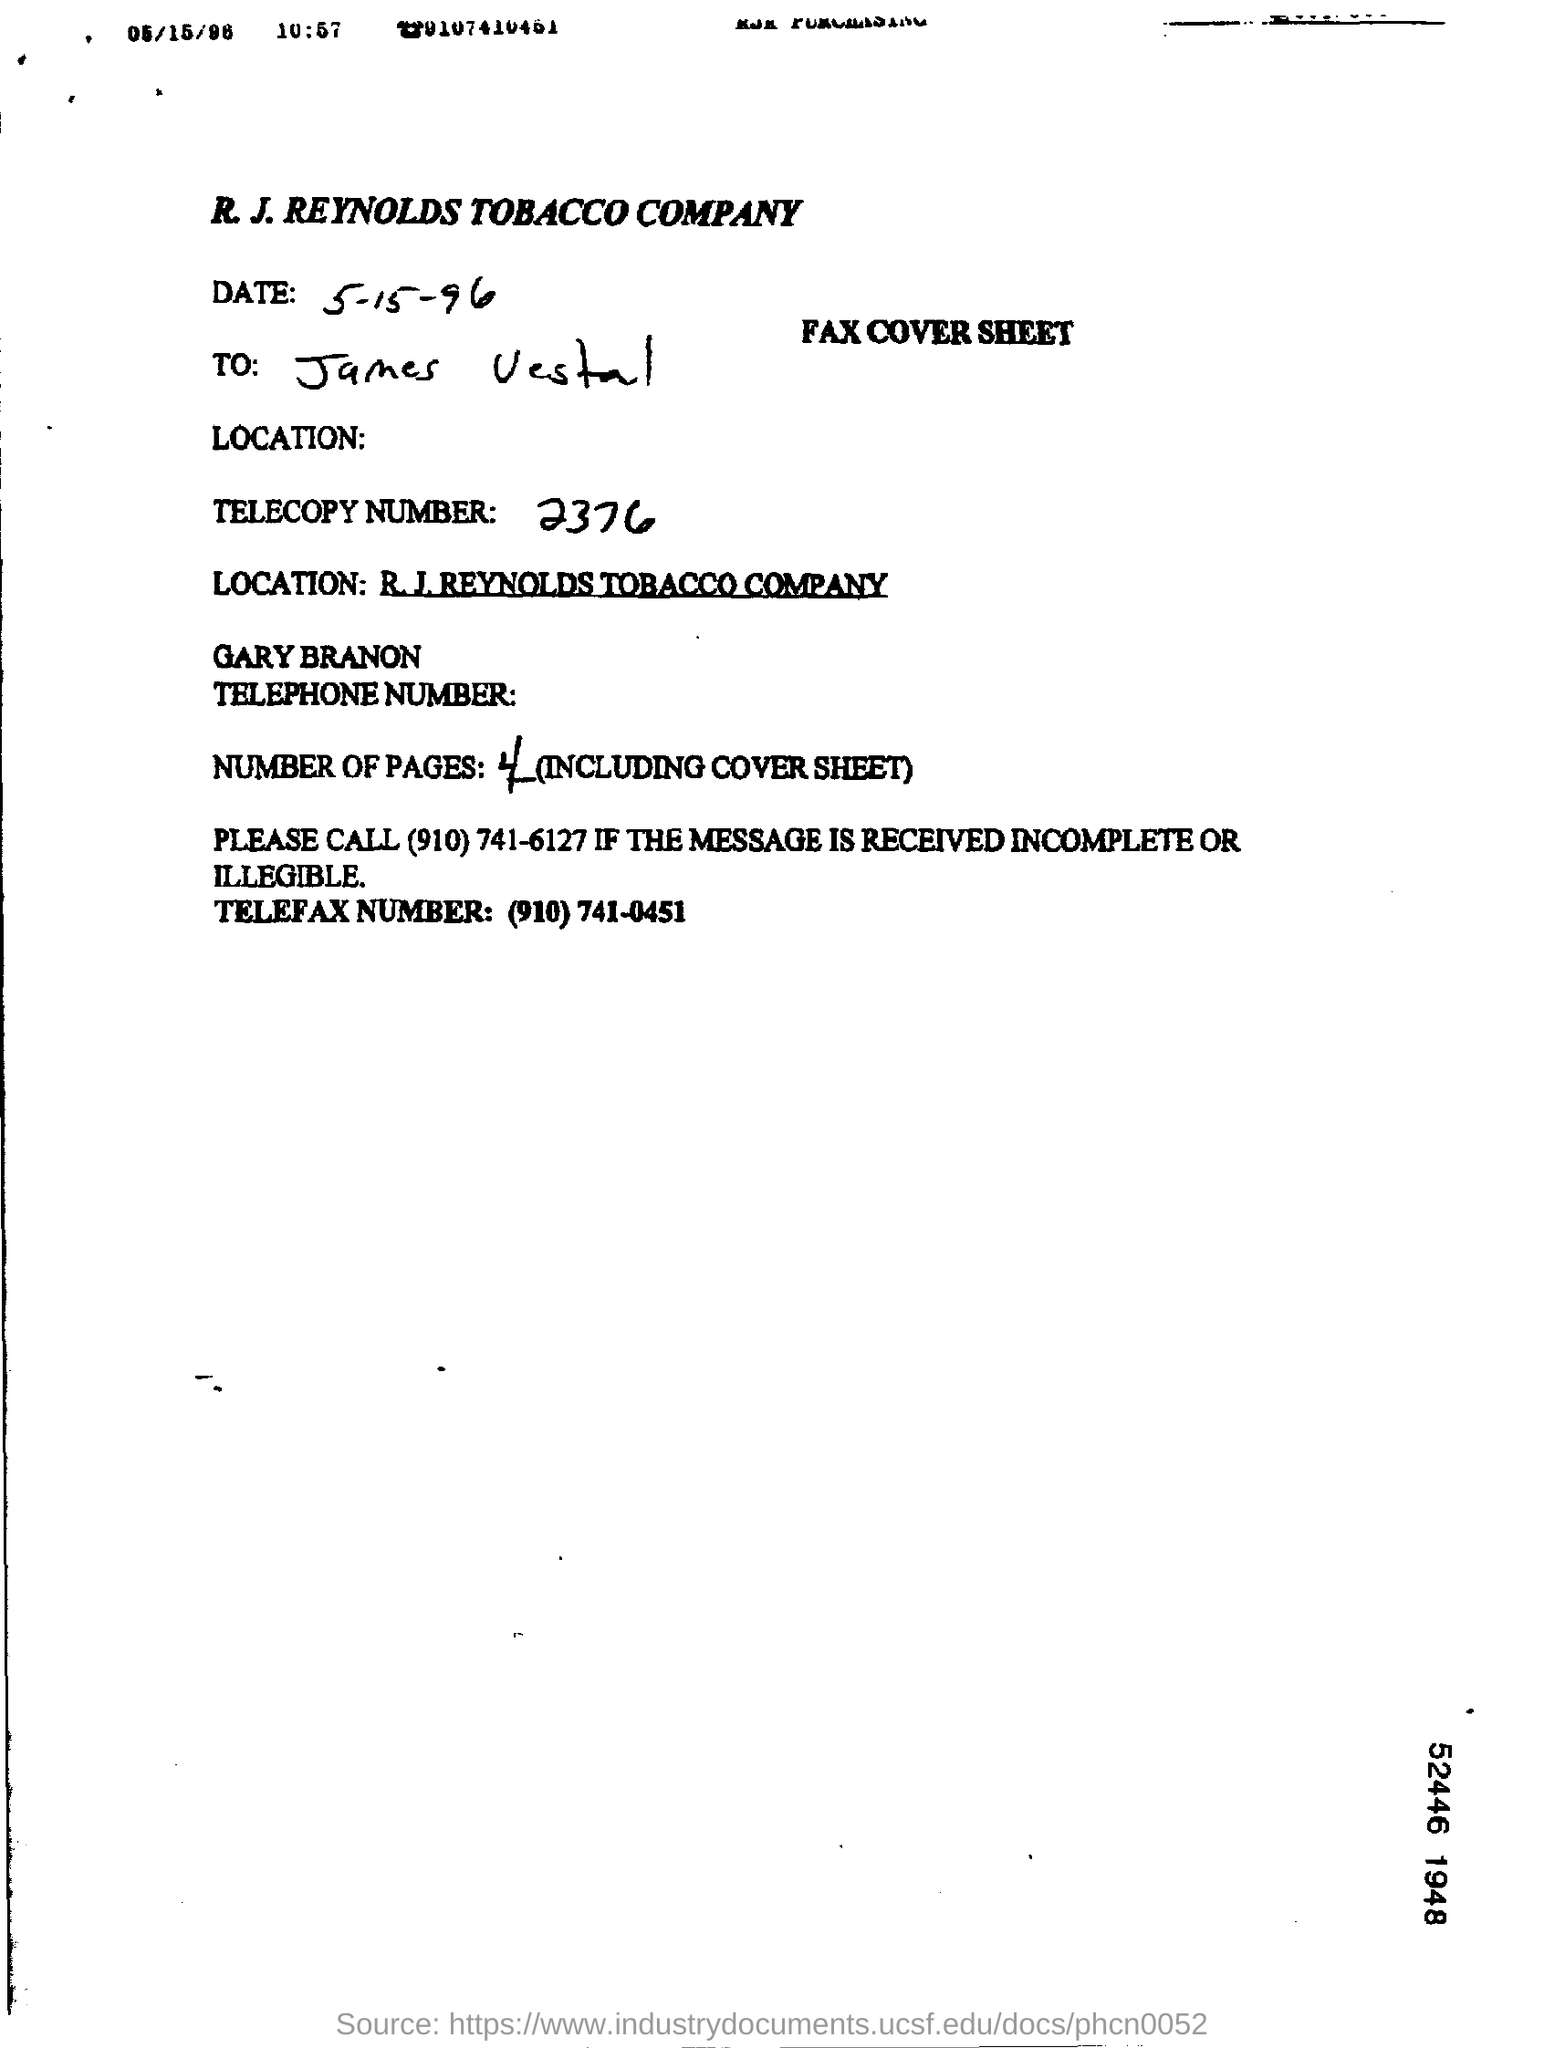What is the date mentioned?
Provide a short and direct response. 5-15-96. 